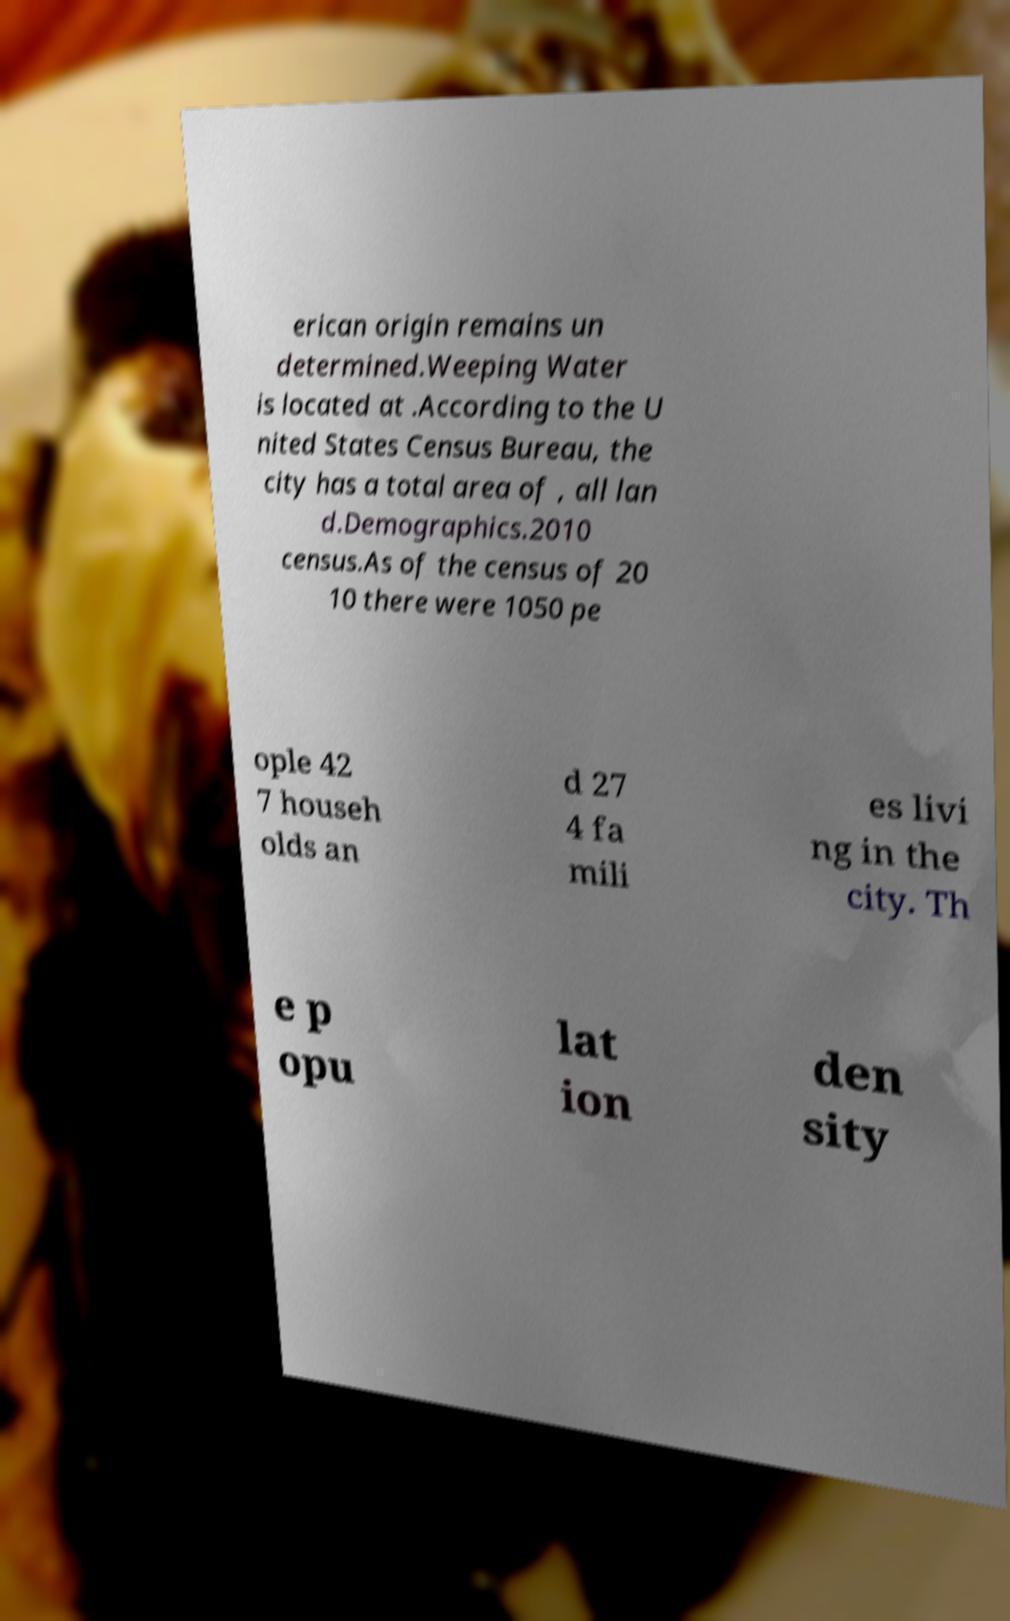Can you read and provide the text displayed in the image?This photo seems to have some interesting text. Can you extract and type it out for me? erican origin remains un determined.Weeping Water is located at .According to the U nited States Census Bureau, the city has a total area of , all lan d.Demographics.2010 census.As of the census of 20 10 there were 1050 pe ople 42 7 househ olds an d 27 4 fa mili es livi ng in the city. Th e p opu lat ion den sity 